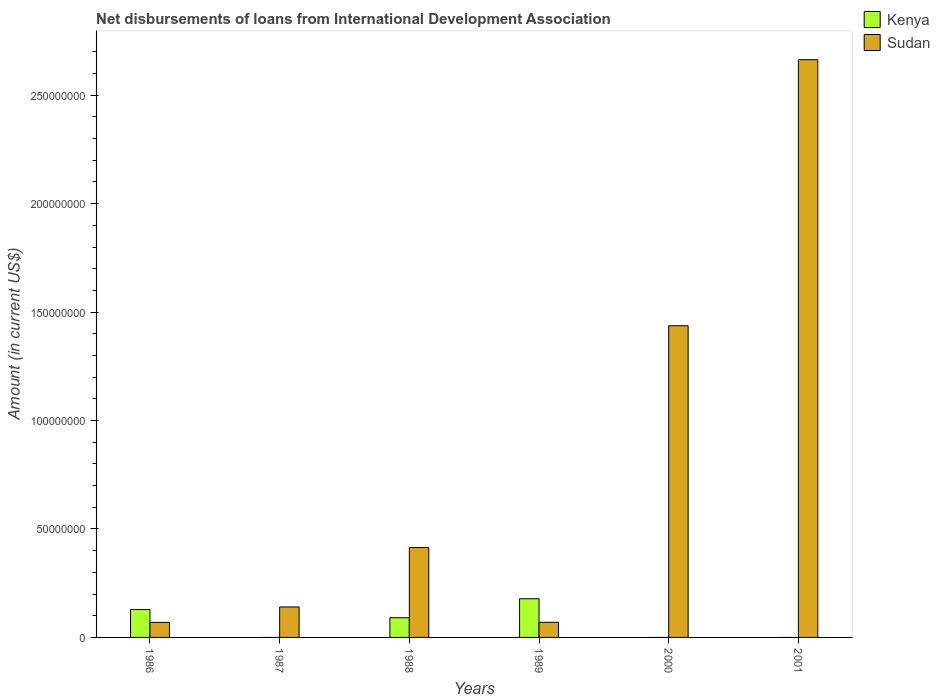How many bars are there on the 5th tick from the left?
Offer a terse response. 1. What is the label of the 6th group of bars from the left?
Your answer should be compact. 2001. What is the amount of loans disbursed in Sudan in 1989?
Provide a succinct answer. 6.98e+06. Across all years, what is the maximum amount of loans disbursed in Sudan?
Keep it short and to the point. 2.66e+08. In which year was the amount of loans disbursed in Kenya maximum?
Your response must be concise. 1989. What is the total amount of loans disbursed in Kenya in the graph?
Provide a short and direct response. 3.98e+07. What is the difference between the amount of loans disbursed in Sudan in 1988 and that in 2001?
Provide a short and direct response. -2.25e+08. What is the difference between the amount of loans disbursed in Kenya in 1987 and the amount of loans disbursed in Sudan in 1989?
Provide a succinct answer. -6.98e+06. What is the average amount of loans disbursed in Kenya per year?
Offer a very short reply. 6.63e+06. In the year 1989, what is the difference between the amount of loans disbursed in Kenya and amount of loans disbursed in Sudan?
Offer a very short reply. 1.09e+07. What is the ratio of the amount of loans disbursed in Kenya in 1986 to that in 1988?
Make the answer very short. 1.41. Is the amount of loans disbursed in Sudan in 1988 less than that in 2001?
Provide a succinct answer. Yes. What is the difference between the highest and the second highest amount of loans disbursed in Kenya?
Your answer should be very brief. 4.99e+06. What is the difference between the highest and the lowest amount of loans disbursed in Sudan?
Offer a very short reply. 2.59e+08. In how many years, is the amount of loans disbursed in Kenya greater than the average amount of loans disbursed in Kenya taken over all years?
Your answer should be compact. 3. How many bars are there?
Your response must be concise. 9. How many years are there in the graph?
Keep it short and to the point. 6. Are the values on the major ticks of Y-axis written in scientific E-notation?
Provide a short and direct response. No. Does the graph contain grids?
Your answer should be compact. No. Where does the legend appear in the graph?
Provide a succinct answer. Top right. How many legend labels are there?
Provide a succinct answer. 2. What is the title of the graph?
Give a very brief answer. Net disbursements of loans from International Development Association. What is the label or title of the X-axis?
Provide a succinct answer. Years. What is the Amount (in current US$) of Kenya in 1986?
Keep it short and to the point. 1.28e+07. What is the Amount (in current US$) in Sudan in 1986?
Your answer should be compact. 6.94e+06. What is the Amount (in current US$) in Sudan in 1987?
Ensure brevity in your answer.  1.40e+07. What is the Amount (in current US$) of Kenya in 1988?
Give a very brief answer. 9.08e+06. What is the Amount (in current US$) of Sudan in 1988?
Keep it short and to the point. 4.14e+07. What is the Amount (in current US$) of Kenya in 1989?
Your answer should be compact. 1.78e+07. What is the Amount (in current US$) in Sudan in 1989?
Offer a very short reply. 6.98e+06. What is the Amount (in current US$) of Kenya in 2000?
Your answer should be very brief. 0. What is the Amount (in current US$) of Sudan in 2000?
Your response must be concise. 1.44e+08. What is the Amount (in current US$) of Sudan in 2001?
Ensure brevity in your answer.  2.66e+08. Across all years, what is the maximum Amount (in current US$) of Kenya?
Your answer should be very brief. 1.78e+07. Across all years, what is the maximum Amount (in current US$) of Sudan?
Ensure brevity in your answer.  2.66e+08. Across all years, what is the minimum Amount (in current US$) of Sudan?
Your answer should be compact. 6.94e+06. What is the total Amount (in current US$) of Kenya in the graph?
Keep it short and to the point. 3.98e+07. What is the total Amount (in current US$) of Sudan in the graph?
Give a very brief answer. 4.79e+08. What is the difference between the Amount (in current US$) of Sudan in 1986 and that in 1987?
Give a very brief answer. -7.11e+06. What is the difference between the Amount (in current US$) of Kenya in 1986 and that in 1988?
Provide a succinct answer. 3.76e+06. What is the difference between the Amount (in current US$) in Sudan in 1986 and that in 1988?
Your response must be concise. -3.45e+07. What is the difference between the Amount (in current US$) of Kenya in 1986 and that in 1989?
Offer a terse response. -4.99e+06. What is the difference between the Amount (in current US$) of Sudan in 1986 and that in 2000?
Ensure brevity in your answer.  -1.37e+08. What is the difference between the Amount (in current US$) of Sudan in 1986 and that in 2001?
Provide a succinct answer. -2.59e+08. What is the difference between the Amount (in current US$) of Sudan in 1987 and that in 1988?
Provide a succinct answer. -2.74e+07. What is the difference between the Amount (in current US$) in Sudan in 1987 and that in 1989?
Provide a succinct answer. 7.07e+06. What is the difference between the Amount (in current US$) in Sudan in 1987 and that in 2000?
Offer a terse response. -1.30e+08. What is the difference between the Amount (in current US$) in Sudan in 1987 and that in 2001?
Offer a terse response. -2.52e+08. What is the difference between the Amount (in current US$) in Kenya in 1988 and that in 1989?
Your response must be concise. -8.76e+06. What is the difference between the Amount (in current US$) of Sudan in 1988 and that in 1989?
Make the answer very short. 3.45e+07. What is the difference between the Amount (in current US$) in Sudan in 1988 and that in 2000?
Keep it short and to the point. -1.02e+08. What is the difference between the Amount (in current US$) of Sudan in 1988 and that in 2001?
Provide a succinct answer. -2.25e+08. What is the difference between the Amount (in current US$) in Sudan in 1989 and that in 2000?
Offer a terse response. -1.37e+08. What is the difference between the Amount (in current US$) in Sudan in 1989 and that in 2001?
Offer a very short reply. -2.59e+08. What is the difference between the Amount (in current US$) of Sudan in 2000 and that in 2001?
Give a very brief answer. -1.23e+08. What is the difference between the Amount (in current US$) of Kenya in 1986 and the Amount (in current US$) of Sudan in 1987?
Ensure brevity in your answer.  -1.20e+06. What is the difference between the Amount (in current US$) in Kenya in 1986 and the Amount (in current US$) in Sudan in 1988?
Offer a terse response. -2.86e+07. What is the difference between the Amount (in current US$) in Kenya in 1986 and the Amount (in current US$) in Sudan in 1989?
Make the answer very short. 5.87e+06. What is the difference between the Amount (in current US$) of Kenya in 1986 and the Amount (in current US$) of Sudan in 2000?
Provide a short and direct response. -1.31e+08. What is the difference between the Amount (in current US$) of Kenya in 1986 and the Amount (in current US$) of Sudan in 2001?
Keep it short and to the point. -2.54e+08. What is the difference between the Amount (in current US$) of Kenya in 1988 and the Amount (in current US$) of Sudan in 1989?
Your answer should be compact. 2.11e+06. What is the difference between the Amount (in current US$) of Kenya in 1988 and the Amount (in current US$) of Sudan in 2000?
Offer a very short reply. -1.35e+08. What is the difference between the Amount (in current US$) in Kenya in 1988 and the Amount (in current US$) in Sudan in 2001?
Your answer should be compact. -2.57e+08. What is the difference between the Amount (in current US$) in Kenya in 1989 and the Amount (in current US$) in Sudan in 2000?
Make the answer very short. -1.26e+08. What is the difference between the Amount (in current US$) of Kenya in 1989 and the Amount (in current US$) of Sudan in 2001?
Offer a very short reply. -2.49e+08. What is the average Amount (in current US$) of Kenya per year?
Provide a short and direct response. 6.63e+06. What is the average Amount (in current US$) in Sudan per year?
Provide a succinct answer. 7.99e+07. In the year 1986, what is the difference between the Amount (in current US$) of Kenya and Amount (in current US$) of Sudan?
Provide a short and direct response. 5.91e+06. In the year 1988, what is the difference between the Amount (in current US$) of Kenya and Amount (in current US$) of Sudan?
Offer a very short reply. -3.24e+07. In the year 1989, what is the difference between the Amount (in current US$) of Kenya and Amount (in current US$) of Sudan?
Offer a very short reply. 1.09e+07. What is the ratio of the Amount (in current US$) of Sudan in 1986 to that in 1987?
Your answer should be compact. 0.49. What is the ratio of the Amount (in current US$) of Kenya in 1986 to that in 1988?
Your response must be concise. 1.41. What is the ratio of the Amount (in current US$) of Sudan in 1986 to that in 1988?
Your answer should be compact. 0.17. What is the ratio of the Amount (in current US$) of Kenya in 1986 to that in 1989?
Give a very brief answer. 0.72. What is the ratio of the Amount (in current US$) of Sudan in 1986 to that in 1989?
Your answer should be compact. 0.99. What is the ratio of the Amount (in current US$) of Sudan in 1986 to that in 2000?
Ensure brevity in your answer.  0.05. What is the ratio of the Amount (in current US$) of Sudan in 1986 to that in 2001?
Provide a succinct answer. 0.03. What is the ratio of the Amount (in current US$) of Sudan in 1987 to that in 1988?
Ensure brevity in your answer.  0.34. What is the ratio of the Amount (in current US$) in Sudan in 1987 to that in 1989?
Give a very brief answer. 2.01. What is the ratio of the Amount (in current US$) in Sudan in 1987 to that in 2000?
Your response must be concise. 0.1. What is the ratio of the Amount (in current US$) of Sudan in 1987 to that in 2001?
Offer a terse response. 0.05. What is the ratio of the Amount (in current US$) of Kenya in 1988 to that in 1989?
Your response must be concise. 0.51. What is the ratio of the Amount (in current US$) in Sudan in 1988 to that in 1989?
Your answer should be compact. 5.94. What is the ratio of the Amount (in current US$) of Sudan in 1988 to that in 2000?
Make the answer very short. 0.29. What is the ratio of the Amount (in current US$) in Sudan in 1988 to that in 2001?
Provide a succinct answer. 0.16. What is the ratio of the Amount (in current US$) in Sudan in 1989 to that in 2000?
Your answer should be very brief. 0.05. What is the ratio of the Amount (in current US$) in Sudan in 1989 to that in 2001?
Offer a very short reply. 0.03. What is the ratio of the Amount (in current US$) in Sudan in 2000 to that in 2001?
Your answer should be very brief. 0.54. What is the difference between the highest and the second highest Amount (in current US$) of Kenya?
Your response must be concise. 4.99e+06. What is the difference between the highest and the second highest Amount (in current US$) in Sudan?
Your response must be concise. 1.23e+08. What is the difference between the highest and the lowest Amount (in current US$) of Kenya?
Keep it short and to the point. 1.78e+07. What is the difference between the highest and the lowest Amount (in current US$) of Sudan?
Offer a terse response. 2.59e+08. 